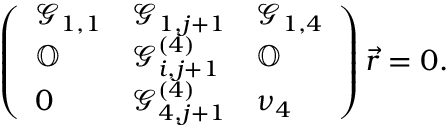Convert formula to latex. <formula><loc_0><loc_0><loc_500><loc_500>\left ( \begin{array} { l l l } { \mathcal { G } _ { 1 , 1 } } & { \mathcal { G } _ { 1 , j + 1 } } & { \mathcal { G } _ { 1 , 4 } } \\ { \mathbb { O } } & { \mathcal { G } _ { i , j + 1 } ^ { ( 4 ) } } & { \mathbb { O } } \\ { 0 } & { \mathcal { G } _ { 4 , j + 1 } ^ { ( 4 ) } } & { \nu _ { 4 } } \end{array} \right ) \vec { r } = 0 .</formula> 